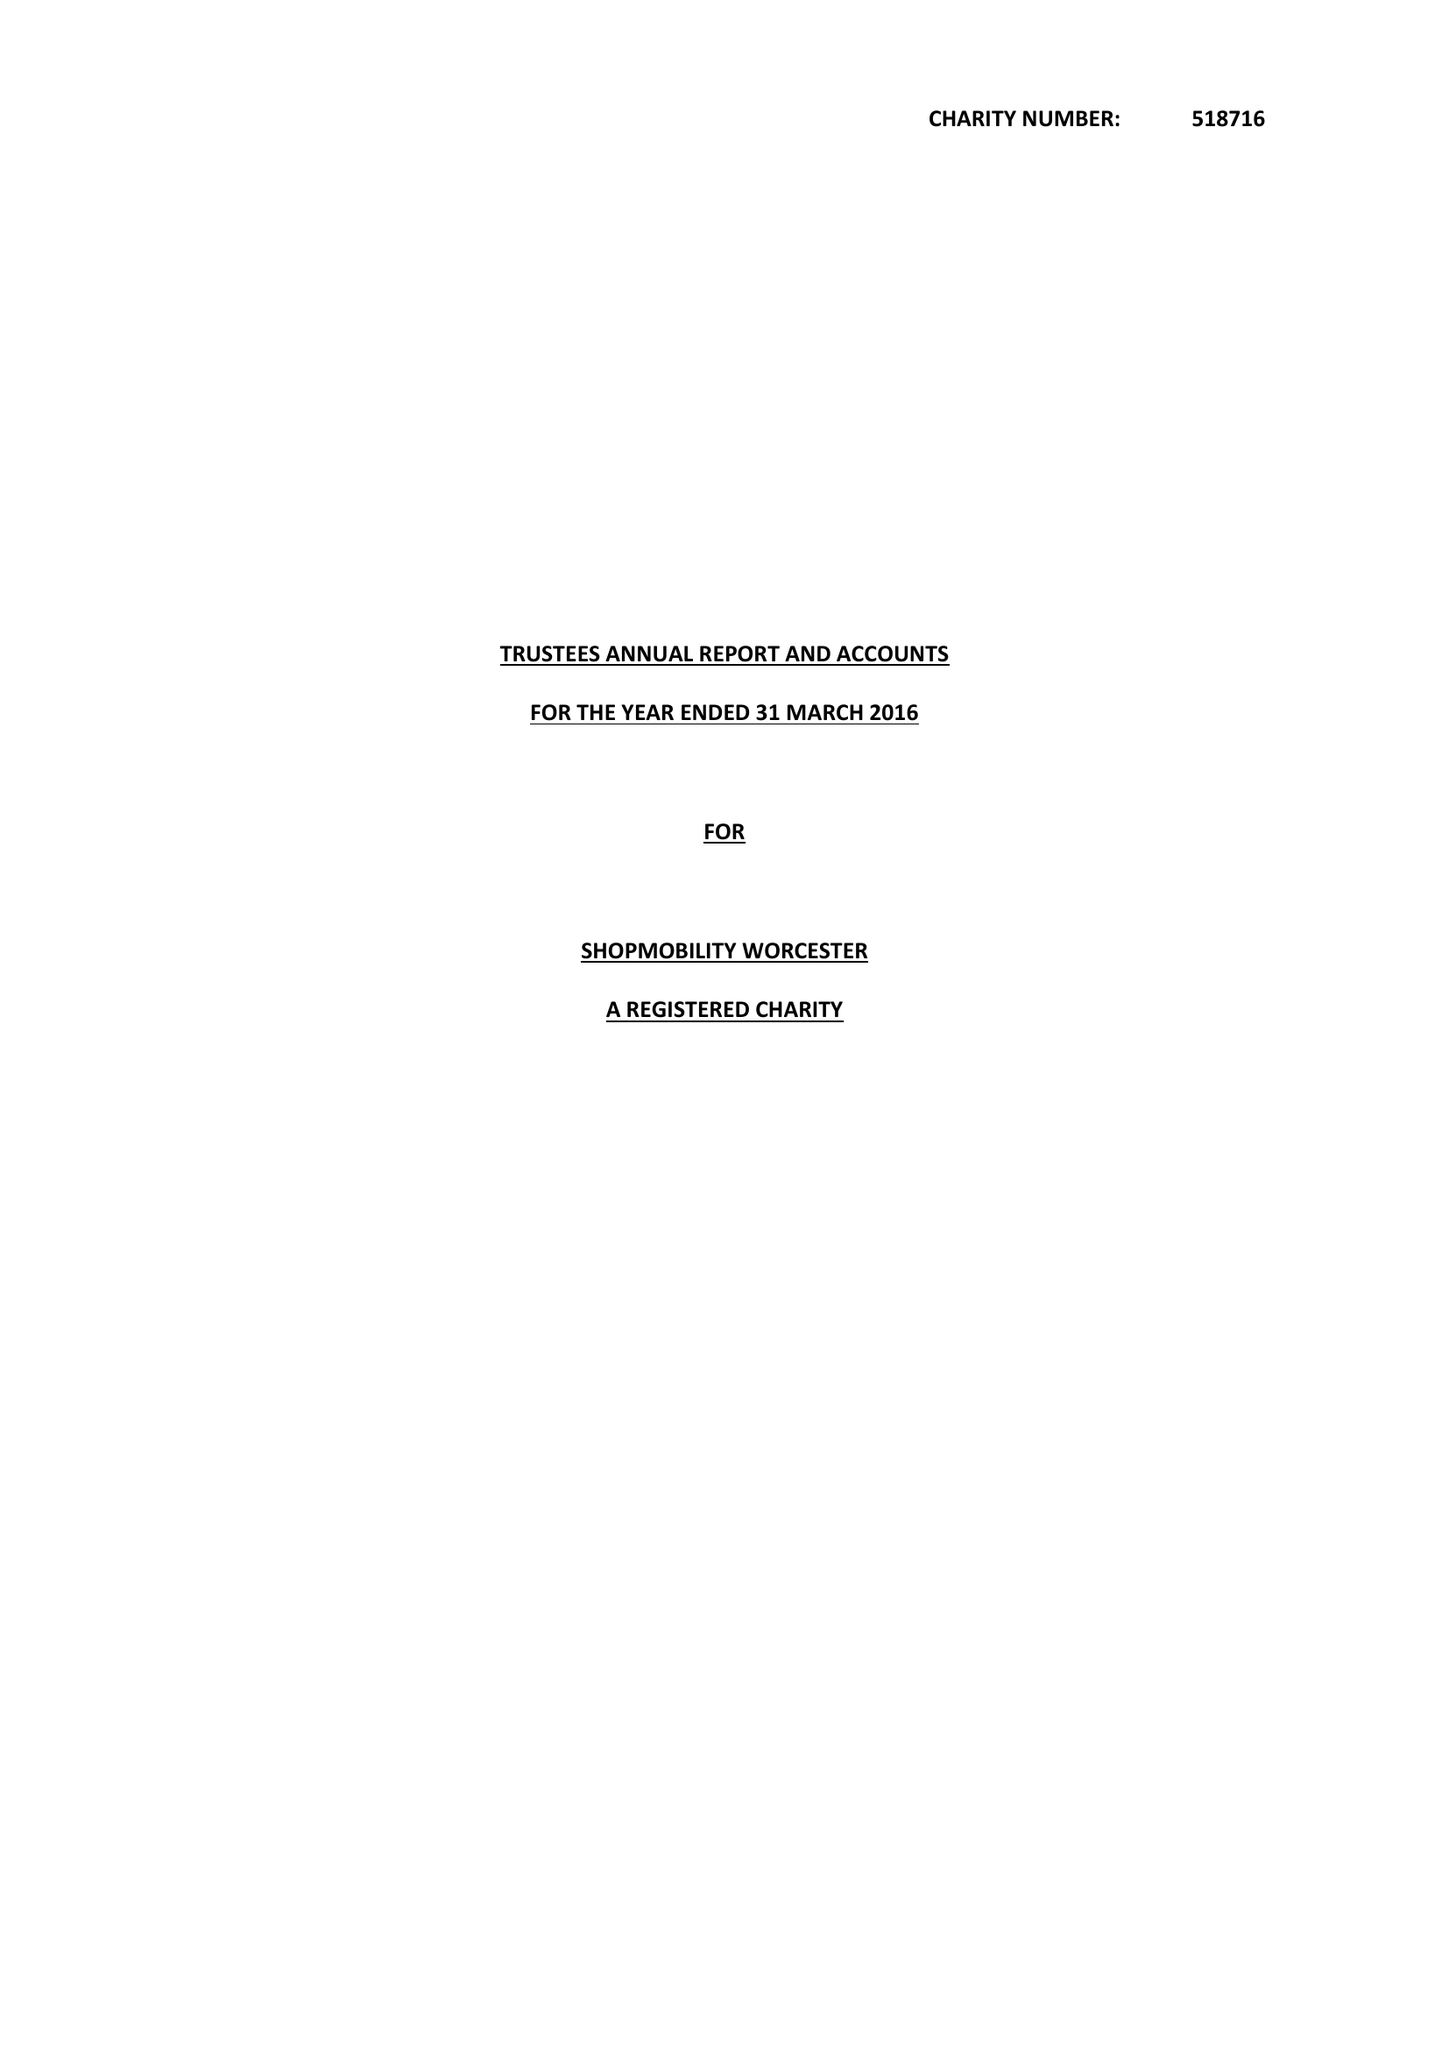What is the value for the report_date?
Answer the question using a single word or phrase. 2016-03-31 